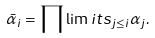Convert formula to latex. <formula><loc_0><loc_0><loc_500><loc_500>\bar { \alpha } _ { i } = \prod \lim i t s _ { j \leq i } \alpha _ { j } .</formula> 